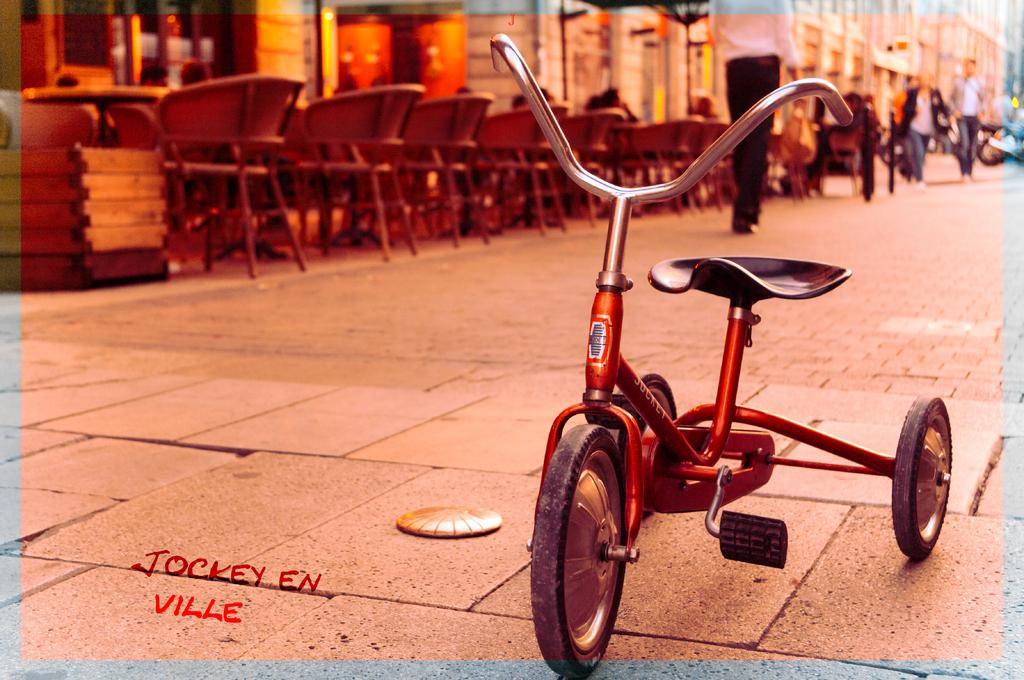What can be seen on the road in the image? There is a small cycle on the road in the image. What type of furniture is visible in the image? There are chairs and tables to the left top of the image. What are the people in the image doing? There are people walking in the image. What can be seen in the distance in the image? There are buildings in the background of the image. What type of quilt is being used to cover the small cycle in the image? There is no quilt present in the image, and the small cycle is not covered. Can you see a hook attached to any of the buildings in the background? There is no hook visible on any of the buildings in the background of the image. 